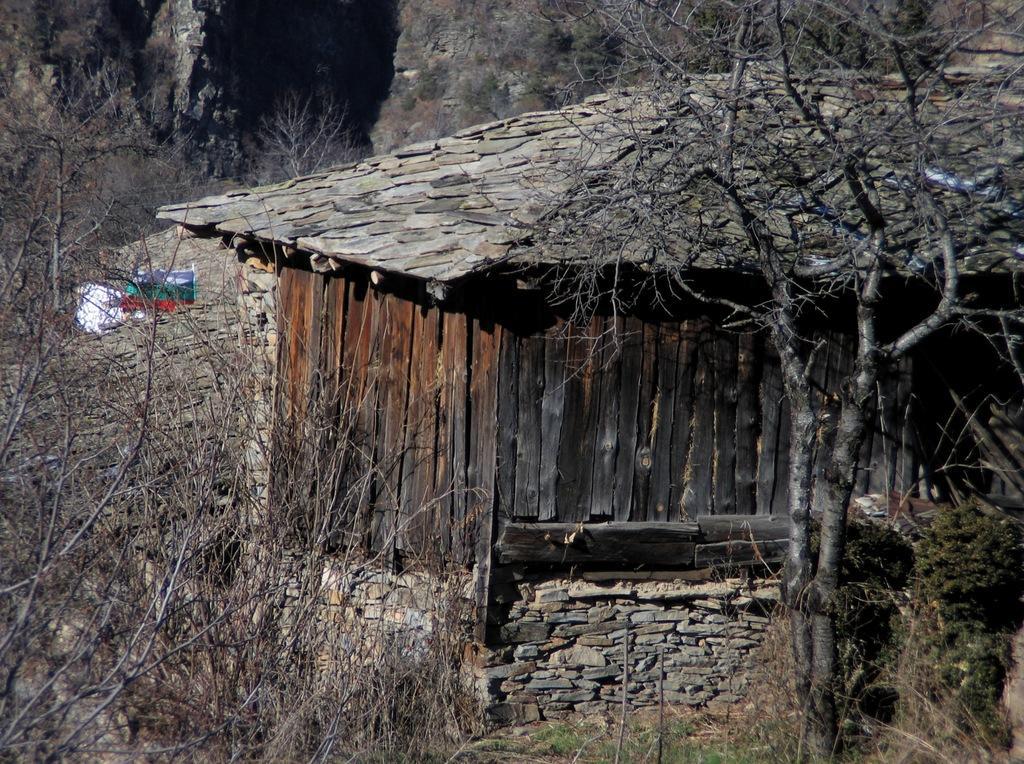Can you describe this image briefly? In this image in the front there are dry trees and in the center there is a hut. In the background there are dry trees. 